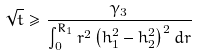Convert formula to latex. <formula><loc_0><loc_0><loc_500><loc_500>\sqrt { t } \geq \frac { \gamma _ { 3 } } { \int _ { 0 } ^ { R _ { 1 } } r ^ { 2 } \left ( h _ { 1 } ^ { 2 } - h _ { 2 } ^ { 2 } \right ) ^ { 2 } d r }</formula> 